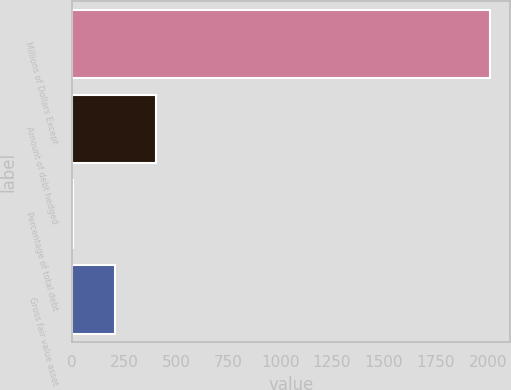Convert chart. <chart><loc_0><loc_0><loc_500><loc_500><bar_chart><fcel>Millions of Dollars Except<fcel>Amount of debt hedged<fcel>Percentage of total debt<fcel>Gross fair value asset<nl><fcel>2008<fcel>404<fcel>3<fcel>203.5<nl></chart> 